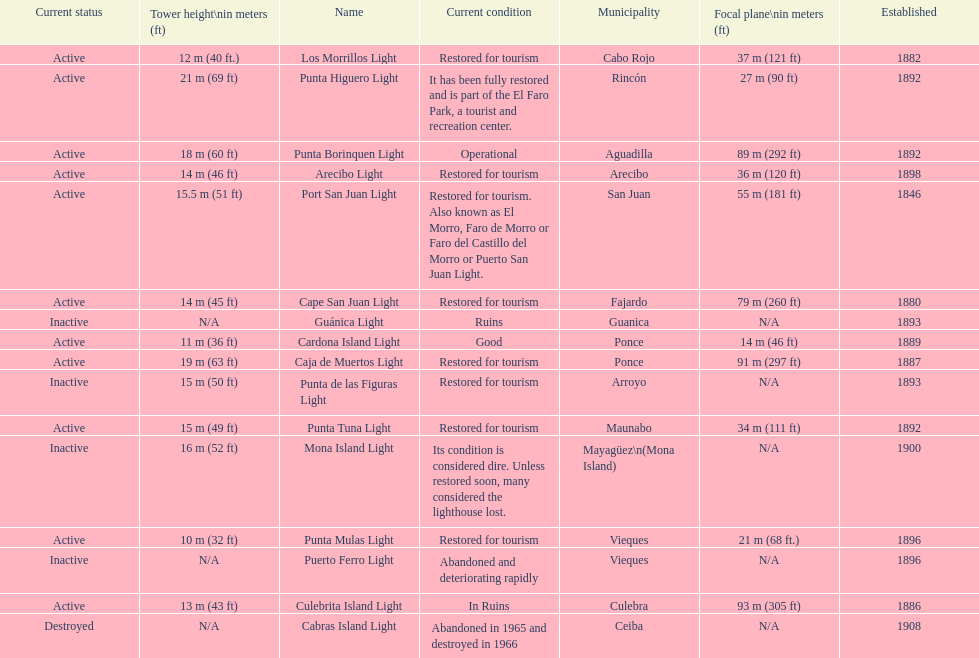Cardona island light and caja de muertos light are both located in what municipality? Ponce. 